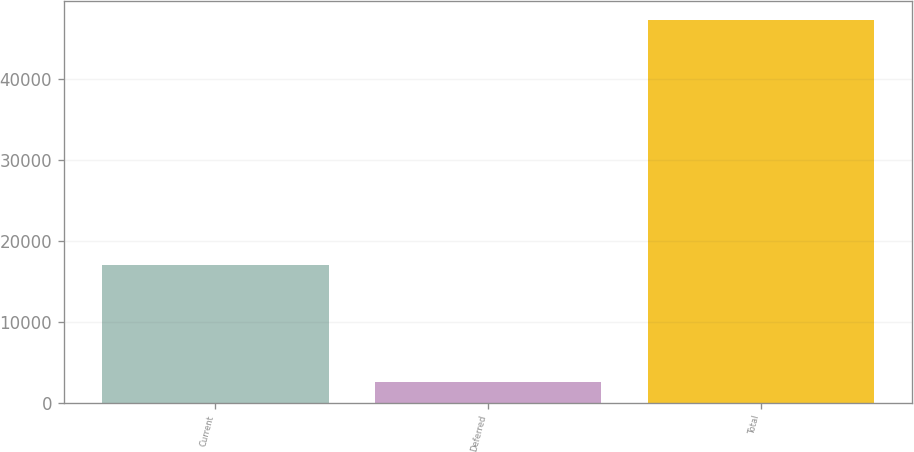Convert chart. <chart><loc_0><loc_0><loc_500><loc_500><bar_chart><fcel>Current<fcel>Deferred<fcel>Total<nl><fcel>17066<fcel>2486<fcel>47309<nl></chart> 